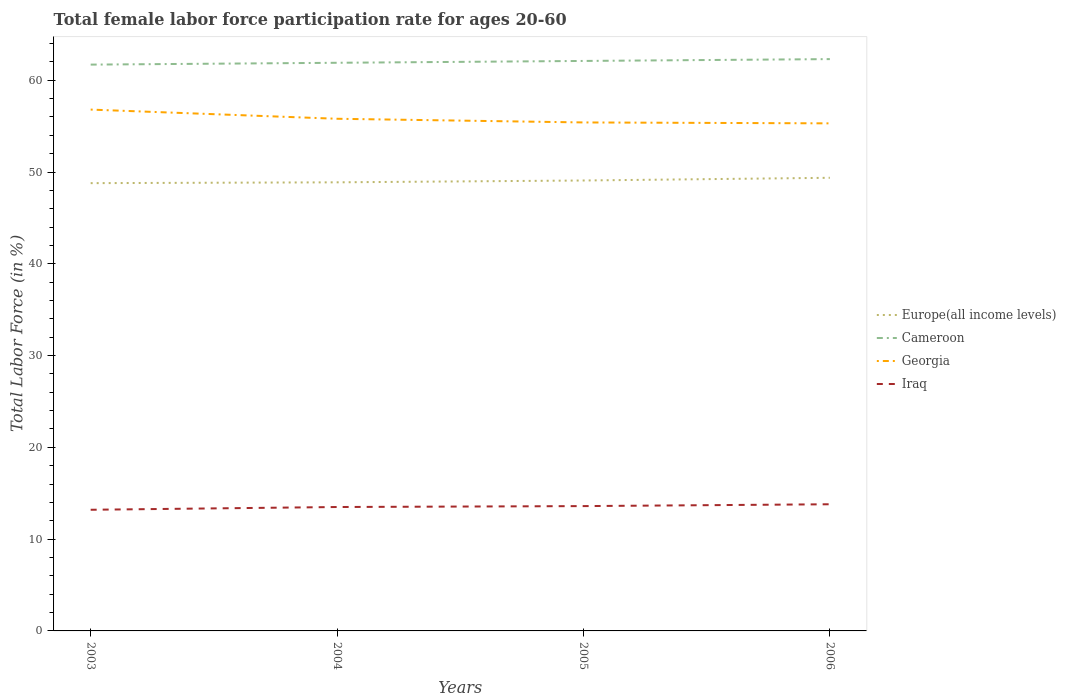Across all years, what is the maximum female labor force participation rate in Georgia?
Provide a short and direct response. 55.3. What is the total female labor force participation rate in Iraq in the graph?
Provide a succinct answer. -0.1. What is the difference between the highest and the second highest female labor force participation rate in Iraq?
Make the answer very short. 0.6. What is the difference between the highest and the lowest female labor force participation rate in Europe(all income levels)?
Offer a terse response. 2. Is the female labor force participation rate in Europe(all income levels) strictly greater than the female labor force participation rate in Cameroon over the years?
Keep it short and to the point. Yes. How many lines are there?
Give a very brief answer. 4. What is the difference between two consecutive major ticks on the Y-axis?
Your answer should be very brief. 10. Does the graph contain any zero values?
Offer a very short reply. No. How are the legend labels stacked?
Provide a short and direct response. Vertical. What is the title of the graph?
Ensure brevity in your answer.  Total female labor force participation rate for ages 20-60. Does "Guinea-Bissau" appear as one of the legend labels in the graph?
Keep it short and to the point. No. What is the label or title of the Y-axis?
Provide a short and direct response. Total Labor Force (in %). What is the Total Labor Force (in %) of Europe(all income levels) in 2003?
Offer a very short reply. 48.79. What is the Total Labor Force (in %) of Cameroon in 2003?
Provide a succinct answer. 61.7. What is the Total Labor Force (in %) in Georgia in 2003?
Make the answer very short. 56.8. What is the Total Labor Force (in %) of Iraq in 2003?
Ensure brevity in your answer.  13.2. What is the Total Labor Force (in %) in Europe(all income levels) in 2004?
Keep it short and to the point. 48.88. What is the Total Labor Force (in %) of Cameroon in 2004?
Your answer should be compact. 61.9. What is the Total Labor Force (in %) of Georgia in 2004?
Keep it short and to the point. 55.8. What is the Total Labor Force (in %) of Europe(all income levels) in 2005?
Ensure brevity in your answer.  49.07. What is the Total Labor Force (in %) of Cameroon in 2005?
Offer a terse response. 62.1. What is the Total Labor Force (in %) of Georgia in 2005?
Make the answer very short. 55.4. What is the Total Labor Force (in %) in Iraq in 2005?
Offer a very short reply. 13.6. What is the Total Labor Force (in %) in Europe(all income levels) in 2006?
Offer a terse response. 49.37. What is the Total Labor Force (in %) in Cameroon in 2006?
Provide a short and direct response. 62.3. What is the Total Labor Force (in %) in Georgia in 2006?
Provide a succinct answer. 55.3. What is the Total Labor Force (in %) in Iraq in 2006?
Your answer should be compact. 13.8. Across all years, what is the maximum Total Labor Force (in %) of Europe(all income levels)?
Provide a short and direct response. 49.37. Across all years, what is the maximum Total Labor Force (in %) of Cameroon?
Offer a terse response. 62.3. Across all years, what is the maximum Total Labor Force (in %) in Georgia?
Give a very brief answer. 56.8. Across all years, what is the maximum Total Labor Force (in %) of Iraq?
Provide a succinct answer. 13.8. Across all years, what is the minimum Total Labor Force (in %) in Europe(all income levels)?
Ensure brevity in your answer.  48.79. Across all years, what is the minimum Total Labor Force (in %) of Cameroon?
Ensure brevity in your answer.  61.7. Across all years, what is the minimum Total Labor Force (in %) in Georgia?
Give a very brief answer. 55.3. Across all years, what is the minimum Total Labor Force (in %) of Iraq?
Offer a terse response. 13.2. What is the total Total Labor Force (in %) in Europe(all income levels) in the graph?
Your answer should be very brief. 196.11. What is the total Total Labor Force (in %) in Cameroon in the graph?
Make the answer very short. 248. What is the total Total Labor Force (in %) of Georgia in the graph?
Provide a succinct answer. 223.3. What is the total Total Labor Force (in %) of Iraq in the graph?
Provide a succinct answer. 54.1. What is the difference between the Total Labor Force (in %) in Europe(all income levels) in 2003 and that in 2004?
Ensure brevity in your answer.  -0.09. What is the difference between the Total Labor Force (in %) of Cameroon in 2003 and that in 2004?
Keep it short and to the point. -0.2. What is the difference between the Total Labor Force (in %) of Iraq in 2003 and that in 2004?
Give a very brief answer. -0.3. What is the difference between the Total Labor Force (in %) in Europe(all income levels) in 2003 and that in 2005?
Your answer should be compact. -0.29. What is the difference between the Total Labor Force (in %) in Europe(all income levels) in 2003 and that in 2006?
Keep it short and to the point. -0.58. What is the difference between the Total Labor Force (in %) in Georgia in 2003 and that in 2006?
Offer a very short reply. 1.5. What is the difference between the Total Labor Force (in %) in Iraq in 2003 and that in 2006?
Your answer should be very brief. -0.6. What is the difference between the Total Labor Force (in %) of Europe(all income levels) in 2004 and that in 2005?
Your response must be concise. -0.2. What is the difference between the Total Labor Force (in %) in Cameroon in 2004 and that in 2005?
Give a very brief answer. -0.2. What is the difference between the Total Labor Force (in %) of Georgia in 2004 and that in 2005?
Give a very brief answer. 0.4. What is the difference between the Total Labor Force (in %) of Europe(all income levels) in 2004 and that in 2006?
Your answer should be compact. -0.49. What is the difference between the Total Labor Force (in %) of Cameroon in 2004 and that in 2006?
Offer a terse response. -0.4. What is the difference between the Total Labor Force (in %) in Europe(all income levels) in 2005 and that in 2006?
Provide a short and direct response. -0.29. What is the difference between the Total Labor Force (in %) of Georgia in 2005 and that in 2006?
Your response must be concise. 0.1. What is the difference between the Total Labor Force (in %) in Iraq in 2005 and that in 2006?
Your response must be concise. -0.2. What is the difference between the Total Labor Force (in %) of Europe(all income levels) in 2003 and the Total Labor Force (in %) of Cameroon in 2004?
Give a very brief answer. -13.11. What is the difference between the Total Labor Force (in %) in Europe(all income levels) in 2003 and the Total Labor Force (in %) in Georgia in 2004?
Make the answer very short. -7.01. What is the difference between the Total Labor Force (in %) in Europe(all income levels) in 2003 and the Total Labor Force (in %) in Iraq in 2004?
Offer a terse response. 35.29. What is the difference between the Total Labor Force (in %) in Cameroon in 2003 and the Total Labor Force (in %) in Iraq in 2004?
Your answer should be compact. 48.2. What is the difference between the Total Labor Force (in %) of Georgia in 2003 and the Total Labor Force (in %) of Iraq in 2004?
Ensure brevity in your answer.  43.3. What is the difference between the Total Labor Force (in %) of Europe(all income levels) in 2003 and the Total Labor Force (in %) of Cameroon in 2005?
Your answer should be very brief. -13.31. What is the difference between the Total Labor Force (in %) in Europe(all income levels) in 2003 and the Total Labor Force (in %) in Georgia in 2005?
Offer a terse response. -6.61. What is the difference between the Total Labor Force (in %) in Europe(all income levels) in 2003 and the Total Labor Force (in %) in Iraq in 2005?
Provide a succinct answer. 35.19. What is the difference between the Total Labor Force (in %) in Cameroon in 2003 and the Total Labor Force (in %) in Georgia in 2005?
Ensure brevity in your answer.  6.3. What is the difference between the Total Labor Force (in %) of Cameroon in 2003 and the Total Labor Force (in %) of Iraq in 2005?
Provide a short and direct response. 48.1. What is the difference between the Total Labor Force (in %) in Georgia in 2003 and the Total Labor Force (in %) in Iraq in 2005?
Your response must be concise. 43.2. What is the difference between the Total Labor Force (in %) in Europe(all income levels) in 2003 and the Total Labor Force (in %) in Cameroon in 2006?
Your answer should be compact. -13.51. What is the difference between the Total Labor Force (in %) of Europe(all income levels) in 2003 and the Total Labor Force (in %) of Georgia in 2006?
Provide a succinct answer. -6.51. What is the difference between the Total Labor Force (in %) in Europe(all income levels) in 2003 and the Total Labor Force (in %) in Iraq in 2006?
Your response must be concise. 34.99. What is the difference between the Total Labor Force (in %) in Cameroon in 2003 and the Total Labor Force (in %) in Georgia in 2006?
Provide a short and direct response. 6.4. What is the difference between the Total Labor Force (in %) in Cameroon in 2003 and the Total Labor Force (in %) in Iraq in 2006?
Make the answer very short. 47.9. What is the difference between the Total Labor Force (in %) in Europe(all income levels) in 2004 and the Total Labor Force (in %) in Cameroon in 2005?
Provide a succinct answer. -13.22. What is the difference between the Total Labor Force (in %) of Europe(all income levels) in 2004 and the Total Labor Force (in %) of Georgia in 2005?
Your answer should be compact. -6.52. What is the difference between the Total Labor Force (in %) in Europe(all income levels) in 2004 and the Total Labor Force (in %) in Iraq in 2005?
Make the answer very short. 35.28. What is the difference between the Total Labor Force (in %) of Cameroon in 2004 and the Total Labor Force (in %) of Iraq in 2005?
Your answer should be very brief. 48.3. What is the difference between the Total Labor Force (in %) in Georgia in 2004 and the Total Labor Force (in %) in Iraq in 2005?
Your response must be concise. 42.2. What is the difference between the Total Labor Force (in %) in Europe(all income levels) in 2004 and the Total Labor Force (in %) in Cameroon in 2006?
Your answer should be compact. -13.42. What is the difference between the Total Labor Force (in %) of Europe(all income levels) in 2004 and the Total Labor Force (in %) of Georgia in 2006?
Your answer should be compact. -6.42. What is the difference between the Total Labor Force (in %) in Europe(all income levels) in 2004 and the Total Labor Force (in %) in Iraq in 2006?
Your response must be concise. 35.08. What is the difference between the Total Labor Force (in %) in Cameroon in 2004 and the Total Labor Force (in %) in Georgia in 2006?
Keep it short and to the point. 6.6. What is the difference between the Total Labor Force (in %) of Cameroon in 2004 and the Total Labor Force (in %) of Iraq in 2006?
Keep it short and to the point. 48.1. What is the difference between the Total Labor Force (in %) of Georgia in 2004 and the Total Labor Force (in %) of Iraq in 2006?
Keep it short and to the point. 42. What is the difference between the Total Labor Force (in %) in Europe(all income levels) in 2005 and the Total Labor Force (in %) in Cameroon in 2006?
Give a very brief answer. -13.23. What is the difference between the Total Labor Force (in %) in Europe(all income levels) in 2005 and the Total Labor Force (in %) in Georgia in 2006?
Provide a short and direct response. -6.23. What is the difference between the Total Labor Force (in %) of Europe(all income levels) in 2005 and the Total Labor Force (in %) of Iraq in 2006?
Offer a terse response. 35.27. What is the difference between the Total Labor Force (in %) in Cameroon in 2005 and the Total Labor Force (in %) in Iraq in 2006?
Offer a terse response. 48.3. What is the difference between the Total Labor Force (in %) of Georgia in 2005 and the Total Labor Force (in %) of Iraq in 2006?
Provide a short and direct response. 41.6. What is the average Total Labor Force (in %) of Europe(all income levels) per year?
Ensure brevity in your answer.  49.03. What is the average Total Labor Force (in %) in Cameroon per year?
Keep it short and to the point. 62. What is the average Total Labor Force (in %) of Georgia per year?
Your response must be concise. 55.83. What is the average Total Labor Force (in %) of Iraq per year?
Your response must be concise. 13.53. In the year 2003, what is the difference between the Total Labor Force (in %) of Europe(all income levels) and Total Labor Force (in %) of Cameroon?
Make the answer very short. -12.91. In the year 2003, what is the difference between the Total Labor Force (in %) in Europe(all income levels) and Total Labor Force (in %) in Georgia?
Offer a very short reply. -8.01. In the year 2003, what is the difference between the Total Labor Force (in %) in Europe(all income levels) and Total Labor Force (in %) in Iraq?
Give a very brief answer. 35.59. In the year 2003, what is the difference between the Total Labor Force (in %) in Cameroon and Total Labor Force (in %) in Georgia?
Offer a very short reply. 4.9. In the year 2003, what is the difference between the Total Labor Force (in %) of Cameroon and Total Labor Force (in %) of Iraq?
Offer a very short reply. 48.5. In the year 2003, what is the difference between the Total Labor Force (in %) of Georgia and Total Labor Force (in %) of Iraq?
Your answer should be compact. 43.6. In the year 2004, what is the difference between the Total Labor Force (in %) in Europe(all income levels) and Total Labor Force (in %) in Cameroon?
Provide a short and direct response. -13.02. In the year 2004, what is the difference between the Total Labor Force (in %) in Europe(all income levels) and Total Labor Force (in %) in Georgia?
Your answer should be compact. -6.92. In the year 2004, what is the difference between the Total Labor Force (in %) of Europe(all income levels) and Total Labor Force (in %) of Iraq?
Your answer should be compact. 35.38. In the year 2004, what is the difference between the Total Labor Force (in %) of Cameroon and Total Labor Force (in %) of Iraq?
Offer a very short reply. 48.4. In the year 2004, what is the difference between the Total Labor Force (in %) of Georgia and Total Labor Force (in %) of Iraq?
Make the answer very short. 42.3. In the year 2005, what is the difference between the Total Labor Force (in %) in Europe(all income levels) and Total Labor Force (in %) in Cameroon?
Provide a succinct answer. -13.03. In the year 2005, what is the difference between the Total Labor Force (in %) of Europe(all income levels) and Total Labor Force (in %) of Georgia?
Give a very brief answer. -6.33. In the year 2005, what is the difference between the Total Labor Force (in %) in Europe(all income levels) and Total Labor Force (in %) in Iraq?
Your answer should be very brief. 35.47. In the year 2005, what is the difference between the Total Labor Force (in %) of Cameroon and Total Labor Force (in %) of Georgia?
Your answer should be very brief. 6.7. In the year 2005, what is the difference between the Total Labor Force (in %) in Cameroon and Total Labor Force (in %) in Iraq?
Give a very brief answer. 48.5. In the year 2005, what is the difference between the Total Labor Force (in %) of Georgia and Total Labor Force (in %) of Iraq?
Your answer should be compact. 41.8. In the year 2006, what is the difference between the Total Labor Force (in %) of Europe(all income levels) and Total Labor Force (in %) of Cameroon?
Ensure brevity in your answer.  -12.93. In the year 2006, what is the difference between the Total Labor Force (in %) of Europe(all income levels) and Total Labor Force (in %) of Georgia?
Your answer should be very brief. -5.93. In the year 2006, what is the difference between the Total Labor Force (in %) of Europe(all income levels) and Total Labor Force (in %) of Iraq?
Your answer should be very brief. 35.57. In the year 2006, what is the difference between the Total Labor Force (in %) in Cameroon and Total Labor Force (in %) in Georgia?
Offer a terse response. 7. In the year 2006, what is the difference between the Total Labor Force (in %) in Cameroon and Total Labor Force (in %) in Iraq?
Make the answer very short. 48.5. In the year 2006, what is the difference between the Total Labor Force (in %) in Georgia and Total Labor Force (in %) in Iraq?
Offer a very short reply. 41.5. What is the ratio of the Total Labor Force (in %) of Georgia in 2003 to that in 2004?
Provide a short and direct response. 1.02. What is the ratio of the Total Labor Force (in %) in Iraq in 2003 to that in 2004?
Your answer should be very brief. 0.98. What is the ratio of the Total Labor Force (in %) in Europe(all income levels) in 2003 to that in 2005?
Ensure brevity in your answer.  0.99. What is the ratio of the Total Labor Force (in %) in Georgia in 2003 to that in 2005?
Make the answer very short. 1.03. What is the ratio of the Total Labor Force (in %) in Iraq in 2003 to that in 2005?
Make the answer very short. 0.97. What is the ratio of the Total Labor Force (in %) in Europe(all income levels) in 2003 to that in 2006?
Provide a succinct answer. 0.99. What is the ratio of the Total Labor Force (in %) of Georgia in 2003 to that in 2006?
Offer a terse response. 1.03. What is the ratio of the Total Labor Force (in %) of Iraq in 2003 to that in 2006?
Offer a very short reply. 0.96. What is the ratio of the Total Labor Force (in %) in Georgia in 2004 to that in 2005?
Your answer should be very brief. 1.01. What is the ratio of the Total Labor Force (in %) of Europe(all income levels) in 2004 to that in 2006?
Make the answer very short. 0.99. What is the ratio of the Total Labor Force (in %) of Cameroon in 2004 to that in 2006?
Provide a succinct answer. 0.99. What is the ratio of the Total Labor Force (in %) of Georgia in 2004 to that in 2006?
Keep it short and to the point. 1.01. What is the ratio of the Total Labor Force (in %) in Iraq in 2004 to that in 2006?
Ensure brevity in your answer.  0.98. What is the ratio of the Total Labor Force (in %) in Cameroon in 2005 to that in 2006?
Keep it short and to the point. 1. What is the ratio of the Total Labor Force (in %) of Georgia in 2005 to that in 2006?
Your answer should be compact. 1. What is the ratio of the Total Labor Force (in %) of Iraq in 2005 to that in 2006?
Your response must be concise. 0.99. What is the difference between the highest and the second highest Total Labor Force (in %) of Europe(all income levels)?
Your answer should be compact. 0.29. What is the difference between the highest and the second highest Total Labor Force (in %) in Georgia?
Ensure brevity in your answer.  1. What is the difference between the highest and the second highest Total Labor Force (in %) in Iraq?
Your answer should be very brief. 0.2. What is the difference between the highest and the lowest Total Labor Force (in %) in Europe(all income levels)?
Provide a short and direct response. 0.58. What is the difference between the highest and the lowest Total Labor Force (in %) in Georgia?
Your answer should be compact. 1.5. What is the difference between the highest and the lowest Total Labor Force (in %) in Iraq?
Make the answer very short. 0.6. 